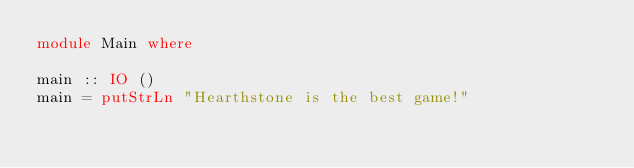Convert code to text. <code><loc_0><loc_0><loc_500><loc_500><_Haskell_>module Main where

main :: IO ()
main = putStrLn "Hearthstone is the best game!"
</code> 